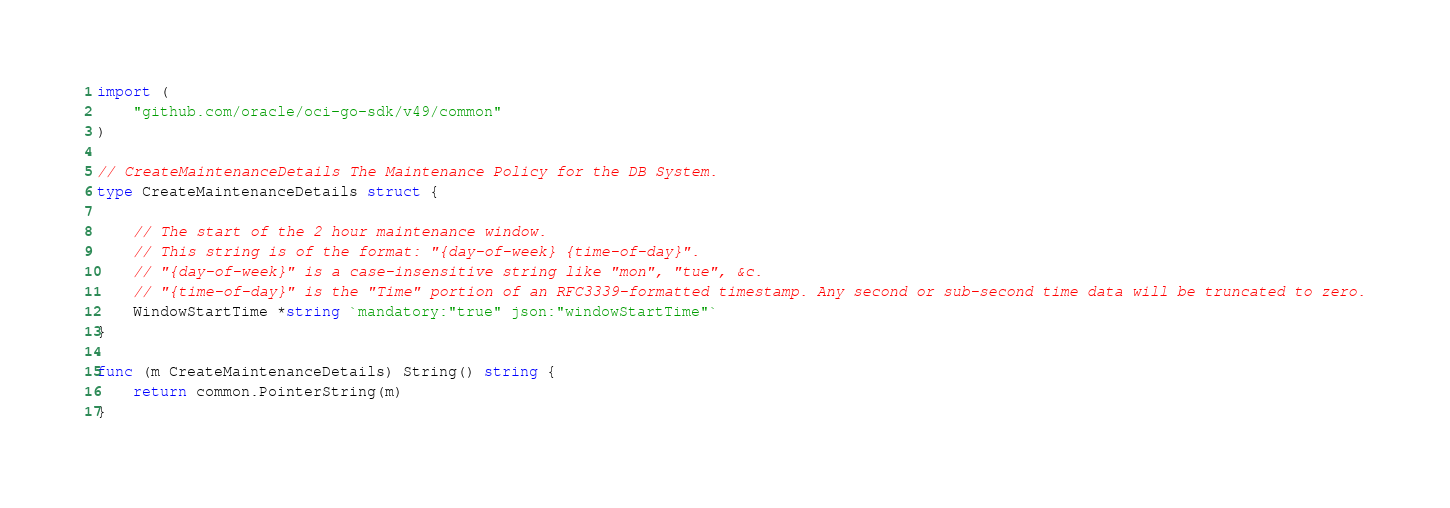<code> <loc_0><loc_0><loc_500><loc_500><_Go_>import (
	"github.com/oracle/oci-go-sdk/v49/common"
)

// CreateMaintenanceDetails The Maintenance Policy for the DB System.
type CreateMaintenanceDetails struct {

	// The start of the 2 hour maintenance window.
	// This string is of the format: "{day-of-week} {time-of-day}".
	// "{day-of-week}" is a case-insensitive string like "mon", "tue", &c.
	// "{time-of-day}" is the "Time" portion of an RFC3339-formatted timestamp. Any second or sub-second time data will be truncated to zero.
	WindowStartTime *string `mandatory:"true" json:"windowStartTime"`
}

func (m CreateMaintenanceDetails) String() string {
	return common.PointerString(m)
}
</code> 